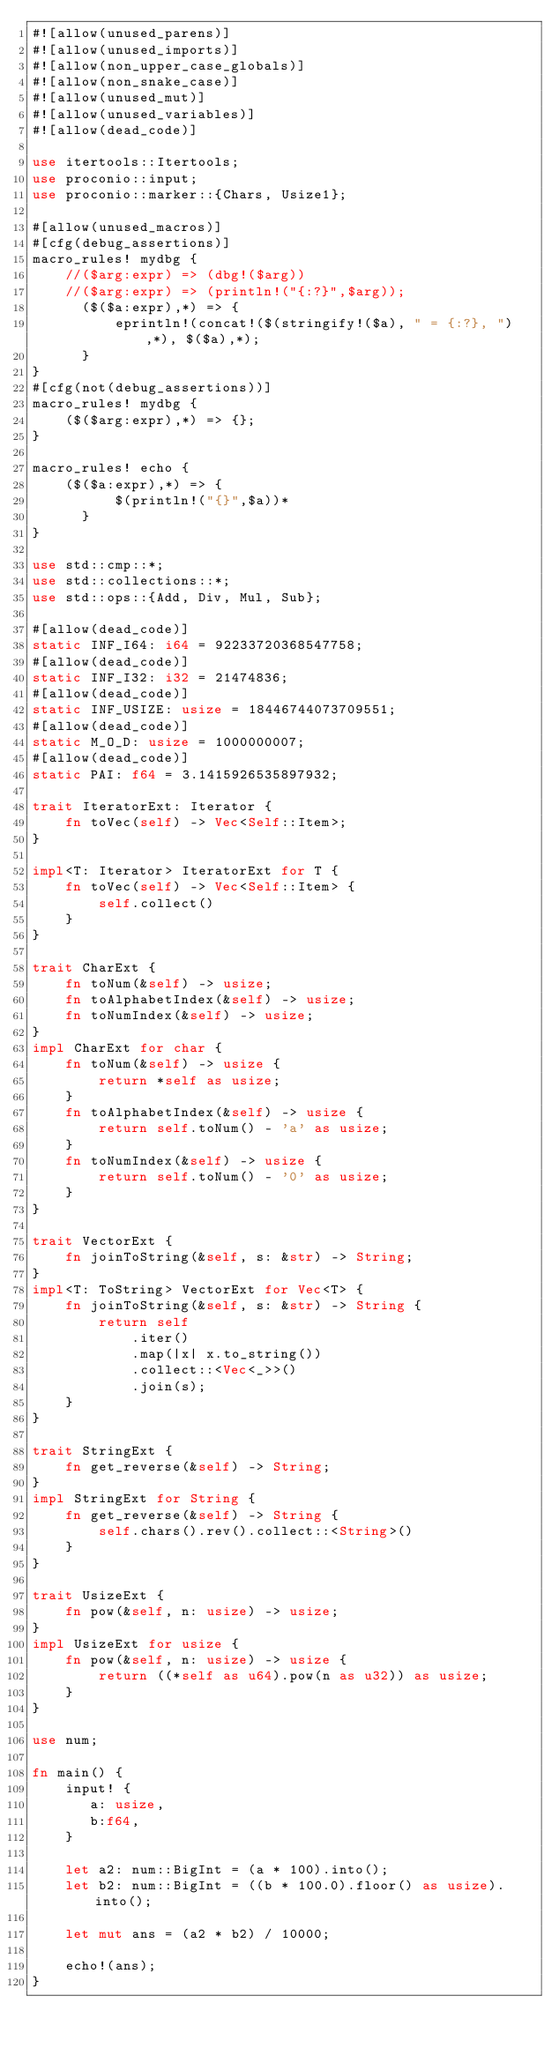Convert code to text. <code><loc_0><loc_0><loc_500><loc_500><_Rust_>#![allow(unused_parens)]
#![allow(unused_imports)]
#![allow(non_upper_case_globals)]
#![allow(non_snake_case)]
#![allow(unused_mut)]
#![allow(unused_variables)]
#![allow(dead_code)]

use itertools::Itertools;
use proconio::input;
use proconio::marker::{Chars, Usize1};

#[allow(unused_macros)]
#[cfg(debug_assertions)]
macro_rules! mydbg {
    //($arg:expr) => (dbg!($arg))
    //($arg:expr) => (println!("{:?}",$arg));
      ($($a:expr),*) => {
          eprintln!(concat!($(stringify!($a), " = {:?}, "),*), $($a),*);
      }
}
#[cfg(not(debug_assertions))]
macro_rules! mydbg {
    ($($arg:expr),*) => {};
}

macro_rules! echo {
    ($($a:expr),*) => {
          $(println!("{}",$a))*
      }
}

use std::cmp::*;
use std::collections::*;
use std::ops::{Add, Div, Mul, Sub};

#[allow(dead_code)]
static INF_I64: i64 = 92233720368547758;
#[allow(dead_code)]
static INF_I32: i32 = 21474836;
#[allow(dead_code)]
static INF_USIZE: usize = 18446744073709551;
#[allow(dead_code)]
static M_O_D: usize = 1000000007;
#[allow(dead_code)]
static PAI: f64 = 3.1415926535897932;

trait IteratorExt: Iterator {
    fn toVec(self) -> Vec<Self::Item>;
}

impl<T: Iterator> IteratorExt for T {
    fn toVec(self) -> Vec<Self::Item> {
        self.collect()
    }
}

trait CharExt {
    fn toNum(&self) -> usize;
    fn toAlphabetIndex(&self) -> usize;
    fn toNumIndex(&self) -> usize;
}
impl CharExt for char {
    fn toNum(&self) -> usize {
        return *self as usize;
    }
    fn toAlphabetIndex(&self) -> usize {
        return self.toNum() - 'a' as usize;
    }
    fn toNumIndex(&self) -> usize {
        return self.toNum() - '0' as usize;
    }
}

trait VectorExt {
    fn joinToString(&self, s: &str) -> String;
}
impl<T: ToString> VectorExt for Vec<T> {
    fn joinToString(&self, s: &str) -> String {
        return self
            .iter()
            .map(|x| x.to_string())
            .collect::<Vec<_>>()
            .join(s);
    }
}

trait StringExt {
    fn get_reverse(&self) -> String;
}
impl StringExt for String {
    fn get_reverse(&self) -> String {
        self.chars().rev().collect::<String>()
    }
}

trait UsizeExt {
    fn pow(&self, n: usize) -> usize;
}
impl UsizeExt for usize {
    fn pow(&self, n: usize) -> usize {
        return ((*self as u64).pow(n as u32)) as usize;
    }
}

use num;

fn main() {
    input! {
       a: usize,
       b:f64,
    }

    let a2: num::BigInt = (a * 100).into();
    let b2: num::BigInt = ((b * 100.0).floor() as usize).into();

    let mut ans = (a2 * b2) / 10000;

    echo!(ans);
}
</code> 